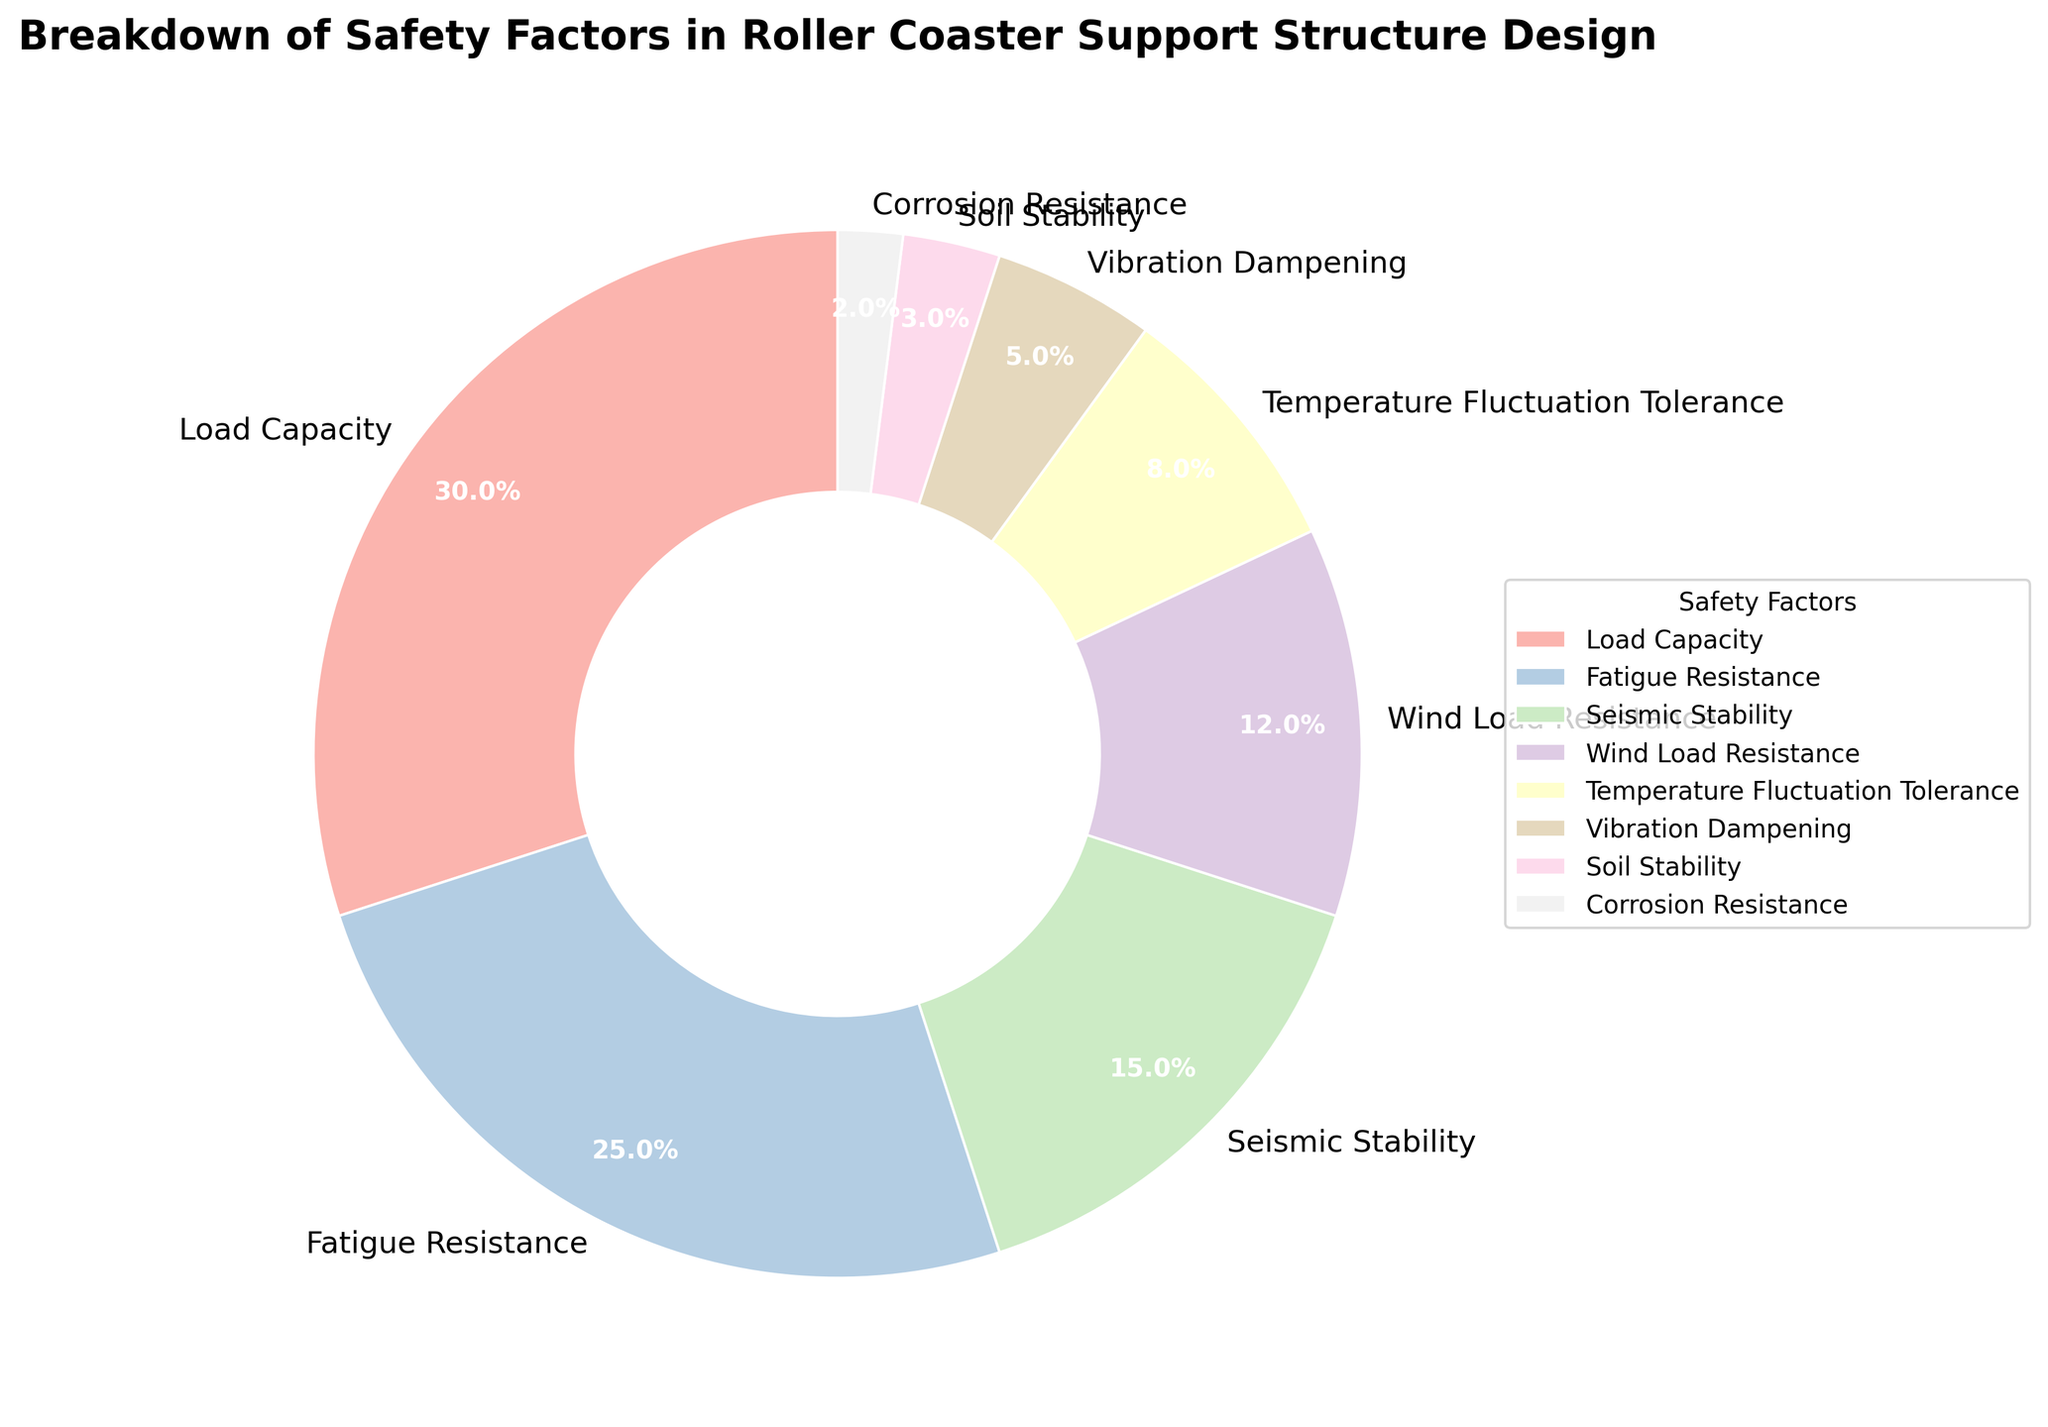What is the safety factor with the largest percentage? By examining the pie chart, we see that the largest segment is labeled "Load Capacity" with 30%.
Answer: Load Capacity Which safety factors have a combined percentage of 40%? By adding the percentages of "Fatigue Resistance" (25%) and "Seismic Stability" (15%) as these are the closest values that total 40%.
Answer: Fatigue Resistance and Seismic Stability What percentage does "Vibration Dampening" contribute to the total? By looking at the pie chart segment labeled "Vibration Dampening," it's clear it contributes 5%.
Answer: 5% Compare the combined percentages of "Load Capacity" and "Fatigue Resistance" against the total percentage of all other factors. Which is larger? "Load Capacity" and "Fatigue Resistance" add up to 30% + 25% = 55%. The total percentage of all other factors is 45%. Thus, 55% > 45%.
Answer: Load Capacity and Fatigue Resistance combined Which safety factor has a lower percentage: "Wind Load Resistance" or "Temperature Fluctuation Tolerance"? "Wind Load Resistance" has 12%, while "Temperature Fluctuation Tolerance" has 8%. Hence, "Temperature Fluctuation Tolerance" has a lower percentage.
Answer: Temperature Fluctuation Tolerance What is the difference in percentage between the largest and smallest safety factors? The largest safety factor "Load Capacity" is 30% and the smallest "Corrosion Resistance" is 2%. The difference between them is 30% - 2% = 28%.
Answer: 28% How many safety factors have a percentage less than 10%? By counting the segments with percentages less than 10%: "Temperature Fluctuation Tolerance" (8%), "Vibration Dampening" (5%), "Soil Stability" (3%), and "Corrosion Resistance" (2%) total to 4 factors.
Answer: 4 What is the combined percentage of safety factors associated with "Load"-related considerations? By adding percentages of "Load Capacity" (30%) and "Wind Load Resistance" (12%) = 30% + 12% = 42%.
Answer: 42% What is the sum of the percentages for "Seismic Stability", "Wind Load Resistance" and "Soil Stability"? Adding the percentages from these factors: "Seismic Stability" (15%) + "Wind Load Resistance" (12%) + "Soil Stability" (3%) = 15% + 12% + 3% = 30%.
Answer: 30% What are the colors used to represent the factors "Fatigue Resistance" and "Corrosion Resistance" in the pie chart? The pie chart uses specific shades of pastel colors for each slice. "Fatigue Resistance" is displayed with a light color, and "Corrosion Resistance" is represented with a different pastel hue.
Answer: Light pastel colors 